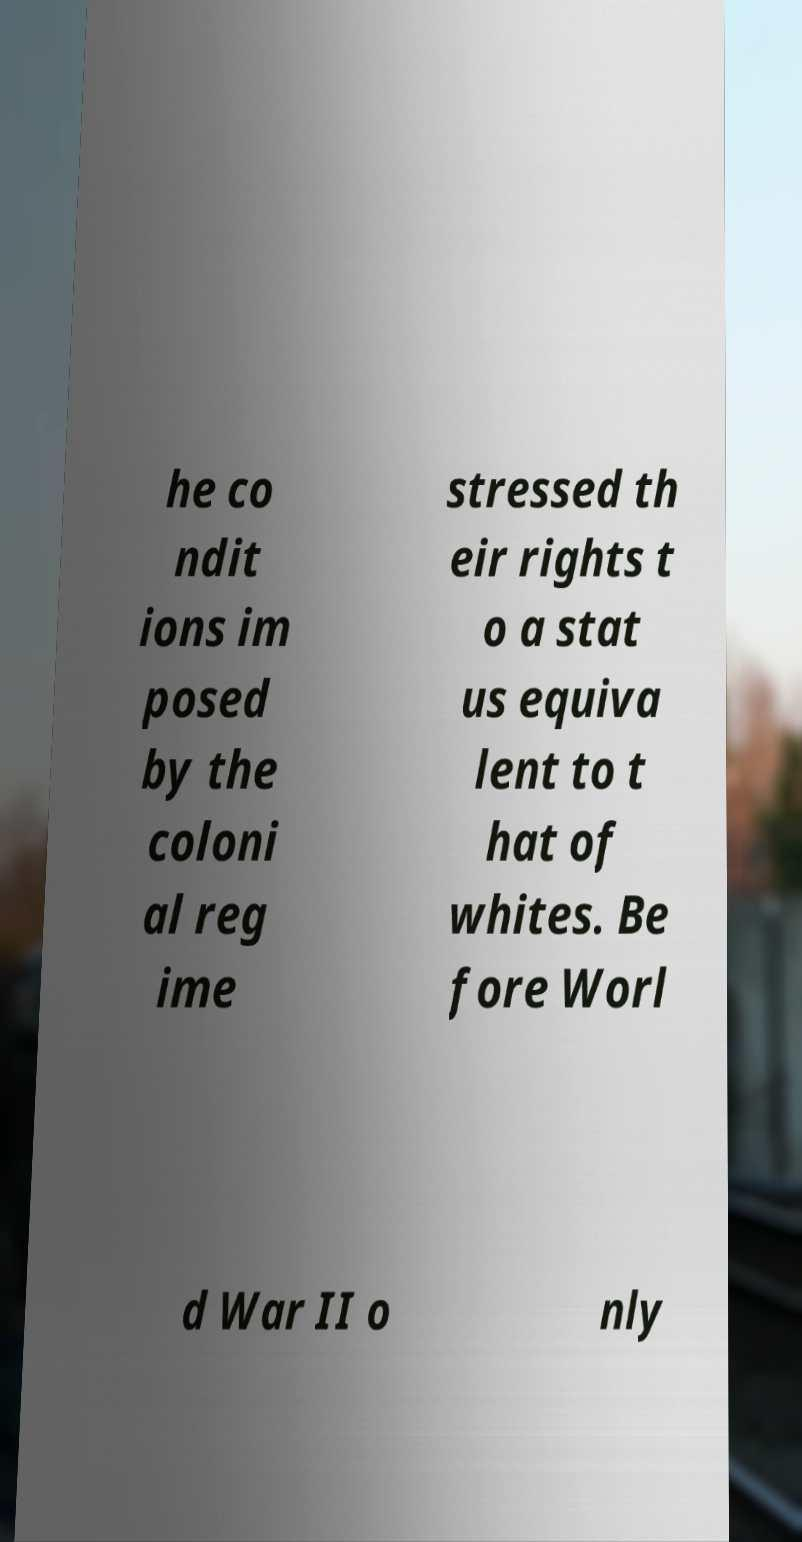Can you accurately transcribe the text from the provided image for me? he co ndit ions im posed by the coloni al reg ime stressed th eir rights t o a stat us equiva lent to t hat of whites. Be fore Worl d War II o nly 